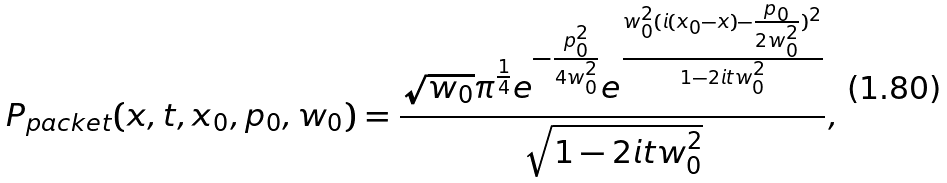<formula> <loc_0><loc_0><loc_500><loc_500>P _ { p a c k e t } ( x , t , x _ { 0 } , p _ { 0 } , w _ { 0 } ) = \frac { \sqrt { w _ { 0 } } \pi ^ { \frac { 1 } { 4 } } e ^ { - \frac { p _ { 0 } ^ { 2 } } { 4 w _ { 0 } ^ { 2 } } } e ^ { \frac { w _ { 0 } ^ { 2 } ( i ( x _ { 0 } - x ) - \frac { p _ { 0 } } { 2 w _ { 0 } ^ { 2 } } ) ^ { 2 } } { 1 - 2 i t w _ { 0 } ^ { 2 } } } } { \sqrt { 1 - 2 i t w _ { 0 } ^ { 2 } } } ,</formula> 